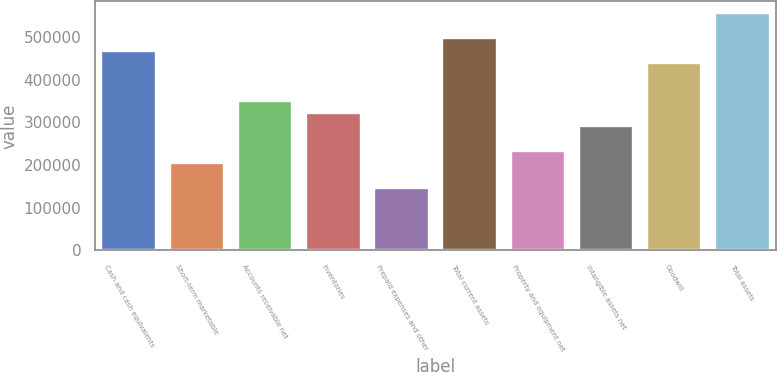Convert chart. <chart><loc_0><loc_0><loc_500><loc_500><bar_chart><fcel>Cash and cash equivalents<fcel>Short-term marketable<fcel>Accounts receivable net<fcel>Inventories<fcel>Prepaid expenses and other<fcel>Total current assets<fcel>Property and equipment net<fcel>Intangible assets net<fcel>Goodwill<fcel>Total assets<nl><fcel>467878<fcel>204762<fcel>350937<fcel>321702<fcel>146292<fcel>497113<fcel>233997<fcel>292467<fcel>438642<fcel>555583<nl></chart> 